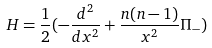<formula> <loc_0><loc_0><loc_500><loc_500>H = \frac { 1 } { 2 } ( - \frac { d ^ { 2 } } { d x ^ { 2 } } + \frac { n ( n - 1 ) } { x ^ { 2 } } \Pi _ { - } )</formula> 